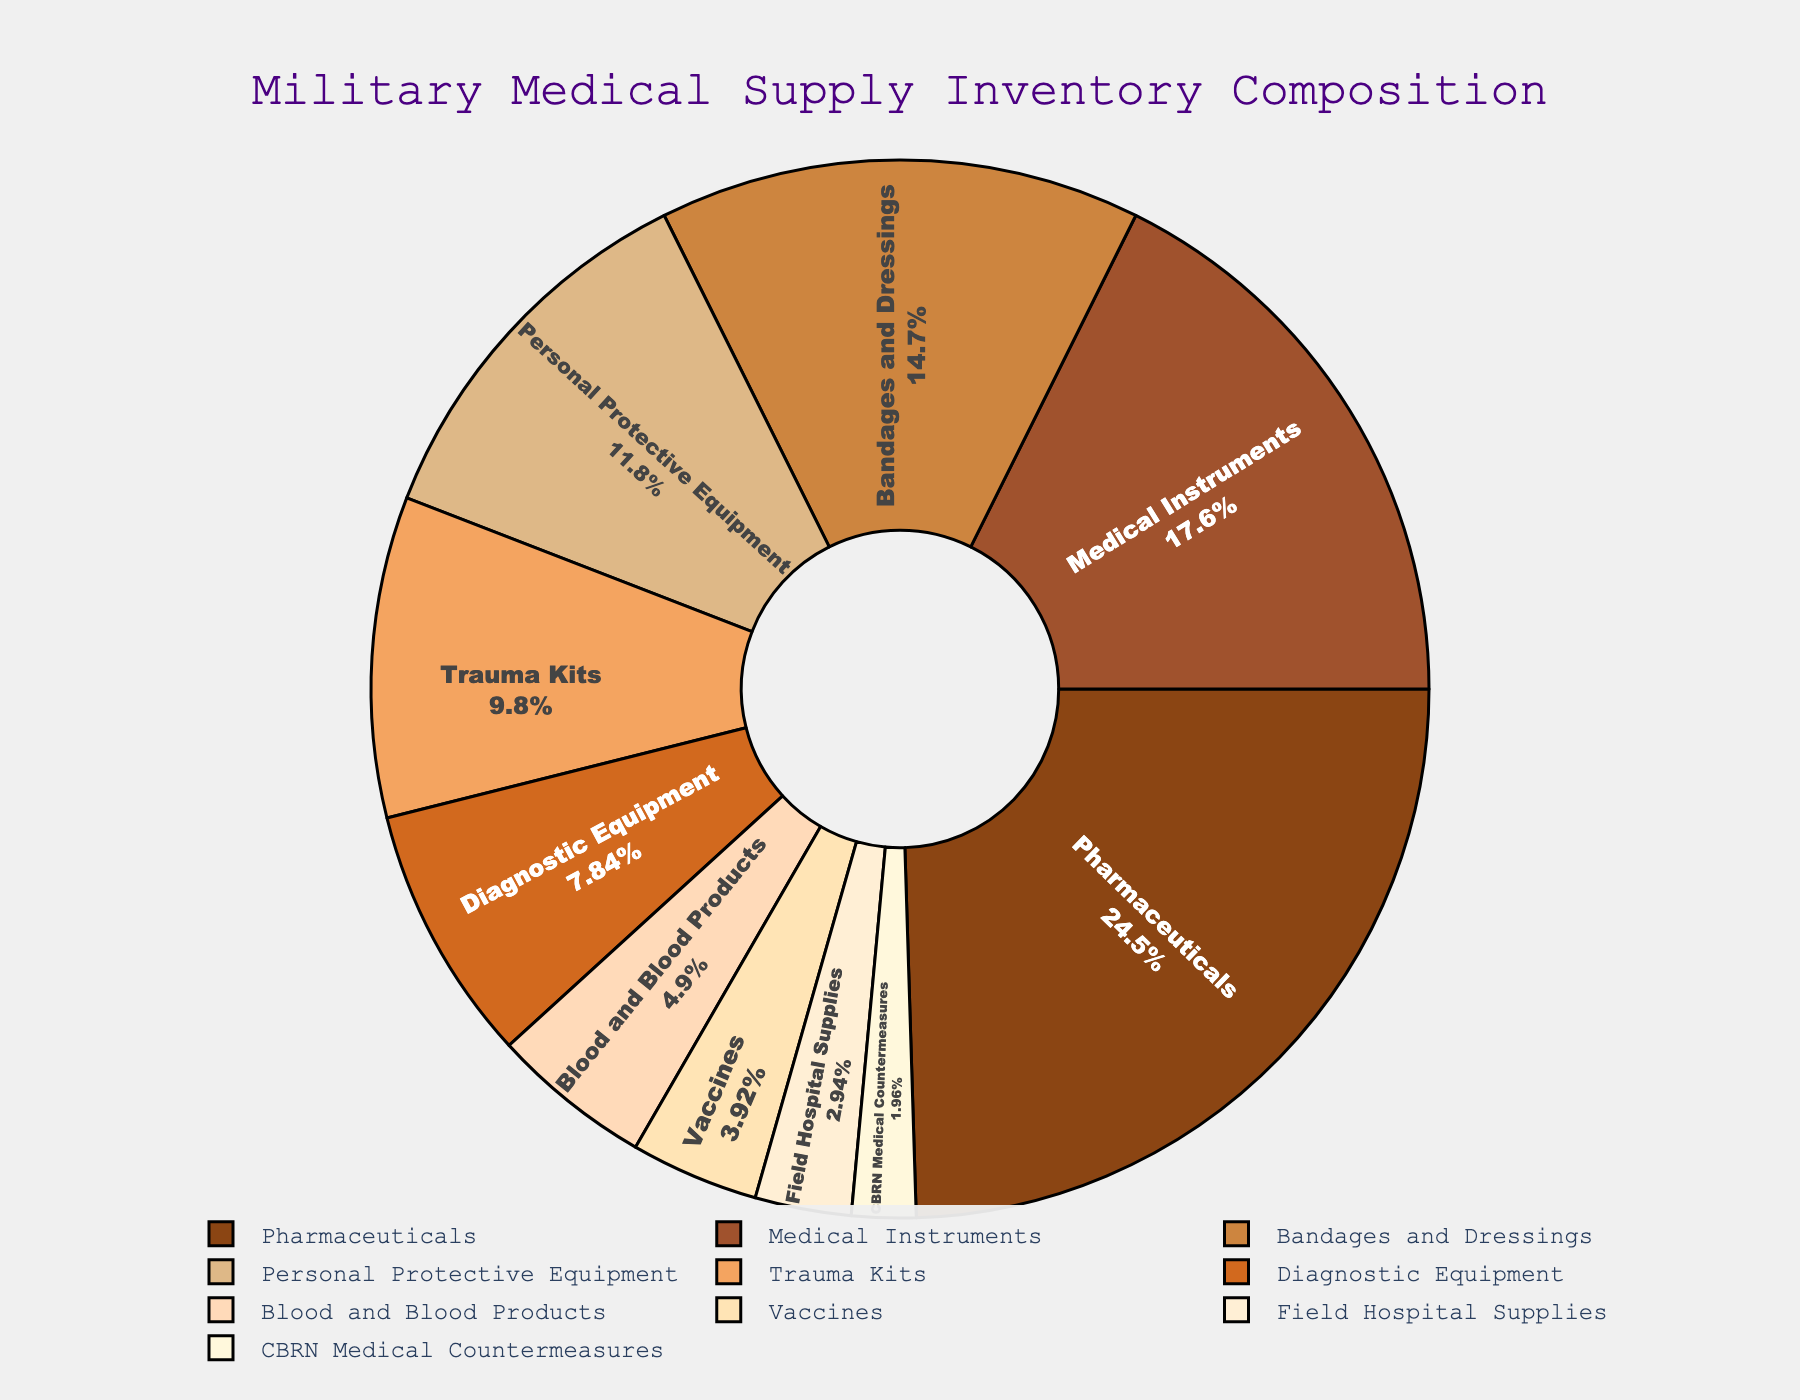What's the largest category by percentage? The largest category can be found by looking at the pie section with the largest area or the highest percentage label. In this chart, it is "Pharmaceuticals" with 25%.
Answer: Pharmaceuticals Which two categories combined make up the largest total percentage? To find the two categories with the largest combined percentage, identify the two largest segments by their percentage values. "Pharmaceuticals" (25%) and "Medical Instruments" (18%) together make up 43%.
Answer: Pharmaceuticals and Medical Instruments How much larger is the Pharmaceuticals category compared to the Blood and Blood Products category? Subtract the percentage of Blood and Blood Products (5%) from the percentage of Pharmaceuticals (25%). The difference is 20%.
Answer: 20% What is the smallest category in this chart? The smallest category can be identified by finding the pie section with the smallest percentage label. In this chart, it is "CBRN Medical Countermeasures" with 2%.
Answer: CBRN Medical Countermeasures Approximately, how much more important are Trauma Kits compared to Field Hospital Supplies in terms of percentage? Subtract the percentage of Field Hospital Supplies (3%) from the percentage of Trauma Kits (10%). The difference is 7%.
Answer: 7% By how much does the sum of Personal Protective Equipment and Bandages and Dressings exceed the sum of Blood and Blood Products and Vaccines? The sum of Personal Protective Equipment (12%) and Bandages and Dressings (15%) is 27%. The sum of Blood and Blood Products (5%) and Vaccines (4%) is 9%. The difference is 27% - 9% = 18%.
Answer: 18% Which category has a percentage close to the sum of Blood and Blood Products and CBRN Medical Countermeasures? The sum of Blood and Blood Products (5%) and CBRN Medical Countermeasures (2%) is 7%. Diagnostic Equipment has a percentage closest to this sum, which is 8%.
Answer: Diagnostic Equipment How do the categories of Bandages and Dressings and Personal Protective Equipment compare in terms of their contribution to the overall inventory? Bandages and Dressings contribute 15% to the overall inventory, while Personal Protective Equipment contributes 12%. Bandages and Dressings contribute 3% more than Personal Protective Equipment.
Answer: Bandages and Dressings contribute more In terms of visual appearance, which categories are represented by the lighter shades of brown in the pie chart? In the pie chart, the lighter shades of brown usually represent smaller percentages. Field Hospital Supplies (3%), Vaccines (4%), Blood and Blood Products (5%), and Diagnostic Equipment (8%) are likely represented by lighter shades.
Answer: Field Hospital Supplies, Vaccines, Blood and Blood Products, Diagnostic Equipment What are the categories contributing to more than 10% each in the supply inventory? Categories contributing more than 10% each can be identified from the pie chart segments shown with more than 10% labels, which are "Pharmaceuticals" (25%), "Medical Instruments" (18%), "Bandages and Dressings" (15%), "Personal Protective Equipment" (12%), and "Trauma Kits" (10%).
Answer: Pharmaceuticals, Medical Instruments, Bandages and Dressings, Personal Protective Equipment, Trauma Kits 